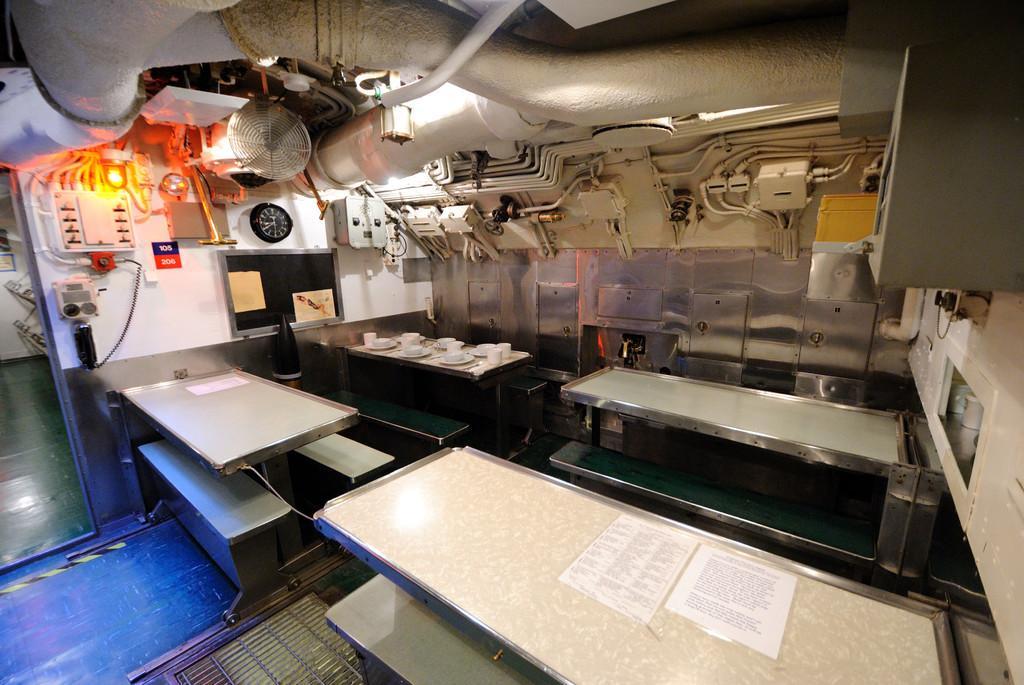Describe this image in one or two sentences. In this image we can see the tables and also the benches. We can also see the menu cards, plates, bowls and also the cups. We can see the floor, wire, clock, fan, light and also the pipes and some other objects. We can also see the wall. 